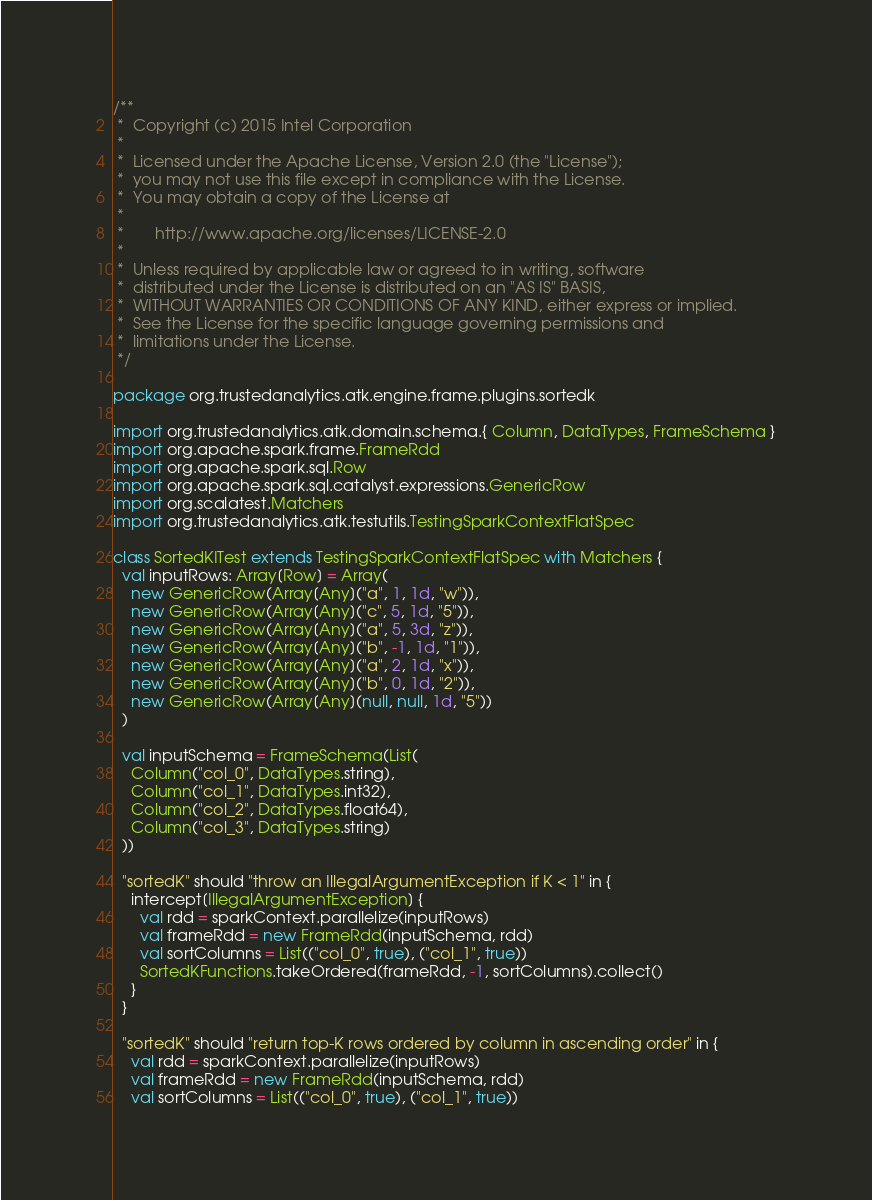<code> <loc_0><loc_0><loc_500><loc_500><_Scala_>/**
 *  Copyright (c) 2015 Intel Corporation 
 *
 *  Licensed under the Apache License, Version 2.0 (the "License");
 *  you may not use this file except in compliance with the License.
 *  You may obtain a copy of the License at
 *
 *       http://www.apache.org/licenses/LICENSE-2.0
 *
 *  Unless required by applicable law or agreed to in writing, software
 *  distributed under the License is distributed on an "AS IS" BASIS,
 *  WITHOUT WARRANTIES OR CONDITIONS OF ANY KIND, either express or implied.
 *  See the License for the specific language governing permissions and
 *  limitations under the License.
 */

package org.trustedanalytics.atk.engine.frame.plugins.sortedk

import org.trustedanalytics.atk.domain.schema.{ Column, DataTypes, FrameSchema }
import org.apache.spark.frame.FrameRdd
import org.apache.spark.sql.Row
import org.apache.spark.sql.catalyst.expressions.GenericRow
import org.scalatest.Matchers
import org.trustedanalytics.atk.testutils.TestingSparkContextFlatSpec

class SortedKITest extends TestingSparkContextFlatSpec with Matchers {
  val inputRows: Array[Row] = Array(
    new GenericRow(Array[Any]("a", 1, 1d, "w")),
    new GenericRow(Array[Any]("c", 5, 1d, "5")),
    new GenericRow(Array[Any]("a", 5, 3d, "z")),
    new GenericRow(Array[Any]("b", -1, 1d, "1")),
    new GenericRow(Array[Any]("a", 2, 1d, "x")),
    new GenericRow(Array[Any]("b", 0, 1d, "2")),
    new GenericRow(Array[Any](null, null, 1d, "5"))
  )

  val inputSchema = FrameSchema(List(
    Column("col_0", DataTypes.string),
    Column("col_1", DataTypes.int32),
    Column("col_2", DataTypes.float64),
    Column("col_3", DataTypes.string)
  ))

  "sortedK" should "throw an IllegalArgumentException if K < 1" in {
    intercept[IllegalArgumentException] {
      val rdd = sparkContext.parallelize(inputRows)
      val frameRdd = new FrameRdd(inputSchema, rdd)
      val sortColumns = List(("col_0", true), ("col_1", true))
      SortedKFunctions.takeOrdered(frameRdd, -1, sortColumns).collect()
    }
  }

  "sortedK" should "return top-K rows ordered by column in ascending order" in {
    val rdd = sparkContext.parallelize(inputRows)
    val frameRdd = new FrameRdd(inputSchema, rdd)
    val sortColumns = List(("col_0", true), ("col_1", true))</code> 